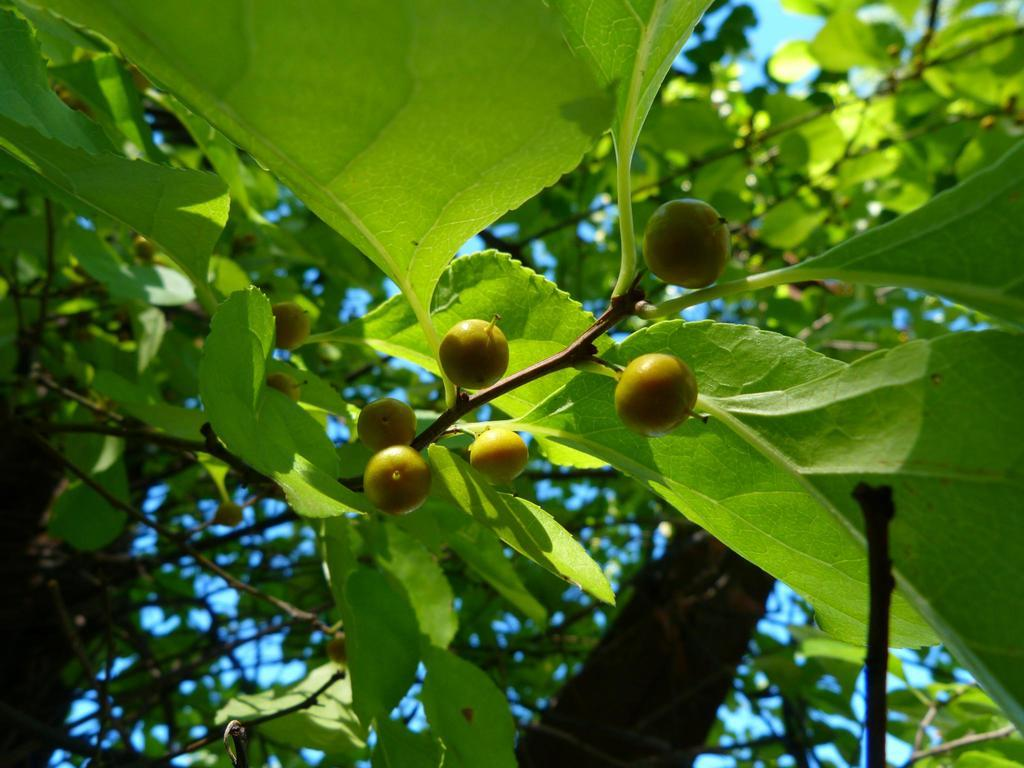What type of vegetation can be seen on the trees in the image? There are fruits on the trees in the image. What else can be seen on the trees besides fruits? There are leaves on the trees in the image. What is visible at the top of the image? The sky is visible at the top of the image. What title is written on the largest fruit in the image? There is no title written on any fruit in the image, as the facts provided do not mention any text or labels. What type of toys can be seen on the branches of the trees in the image? There are no toys present in the image; it only features trees with fruits and leaves. 